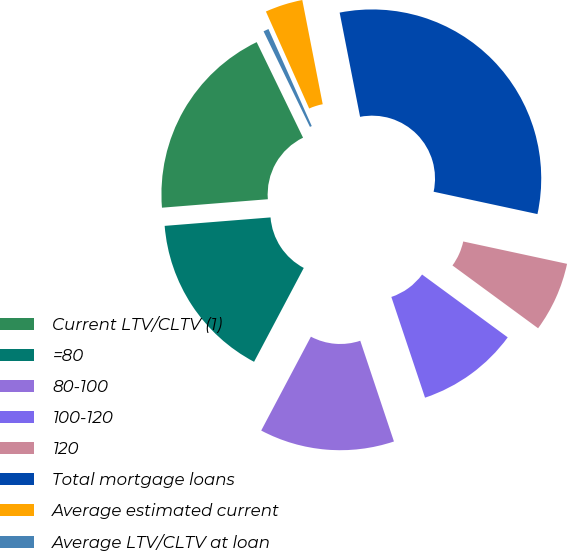Convert chart. <chart><loc_0><loc_0><loc_500><loc_500><pie_chart><fcel>Current LTV/CLTV (1)<fcel>=80<fcel>80-100<fcel>100-120<fcel>120<fcel>Total mortgage loans<fcel>Average estimated current<fcel>Average LTV/CLTV at loan<nl><fcel>19.08%<fcel>15.98%<fcel>12.89%<fcel>9.79%<fcel>6.7%<fcel>31.46%<fcel>3.6%<fcel>0.51%<nl></chart> 